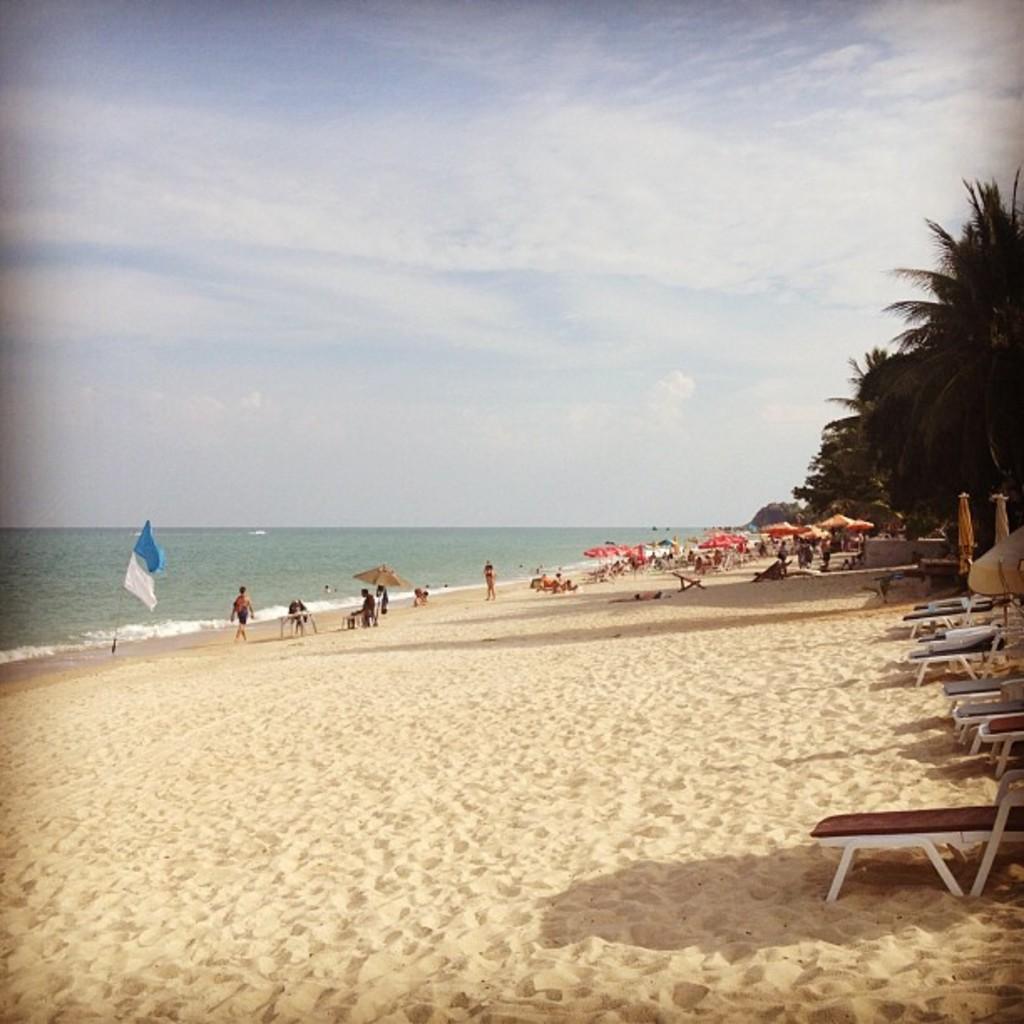In one or two sentences, can you explain what this image depicts? In this image I see the sand and I see chairs over here and I see number of people over here and I see few umbrellas and I see number of trees. In the background I see the water and the clear sky and over here I see 2 clothes which are of white and blue in color. 